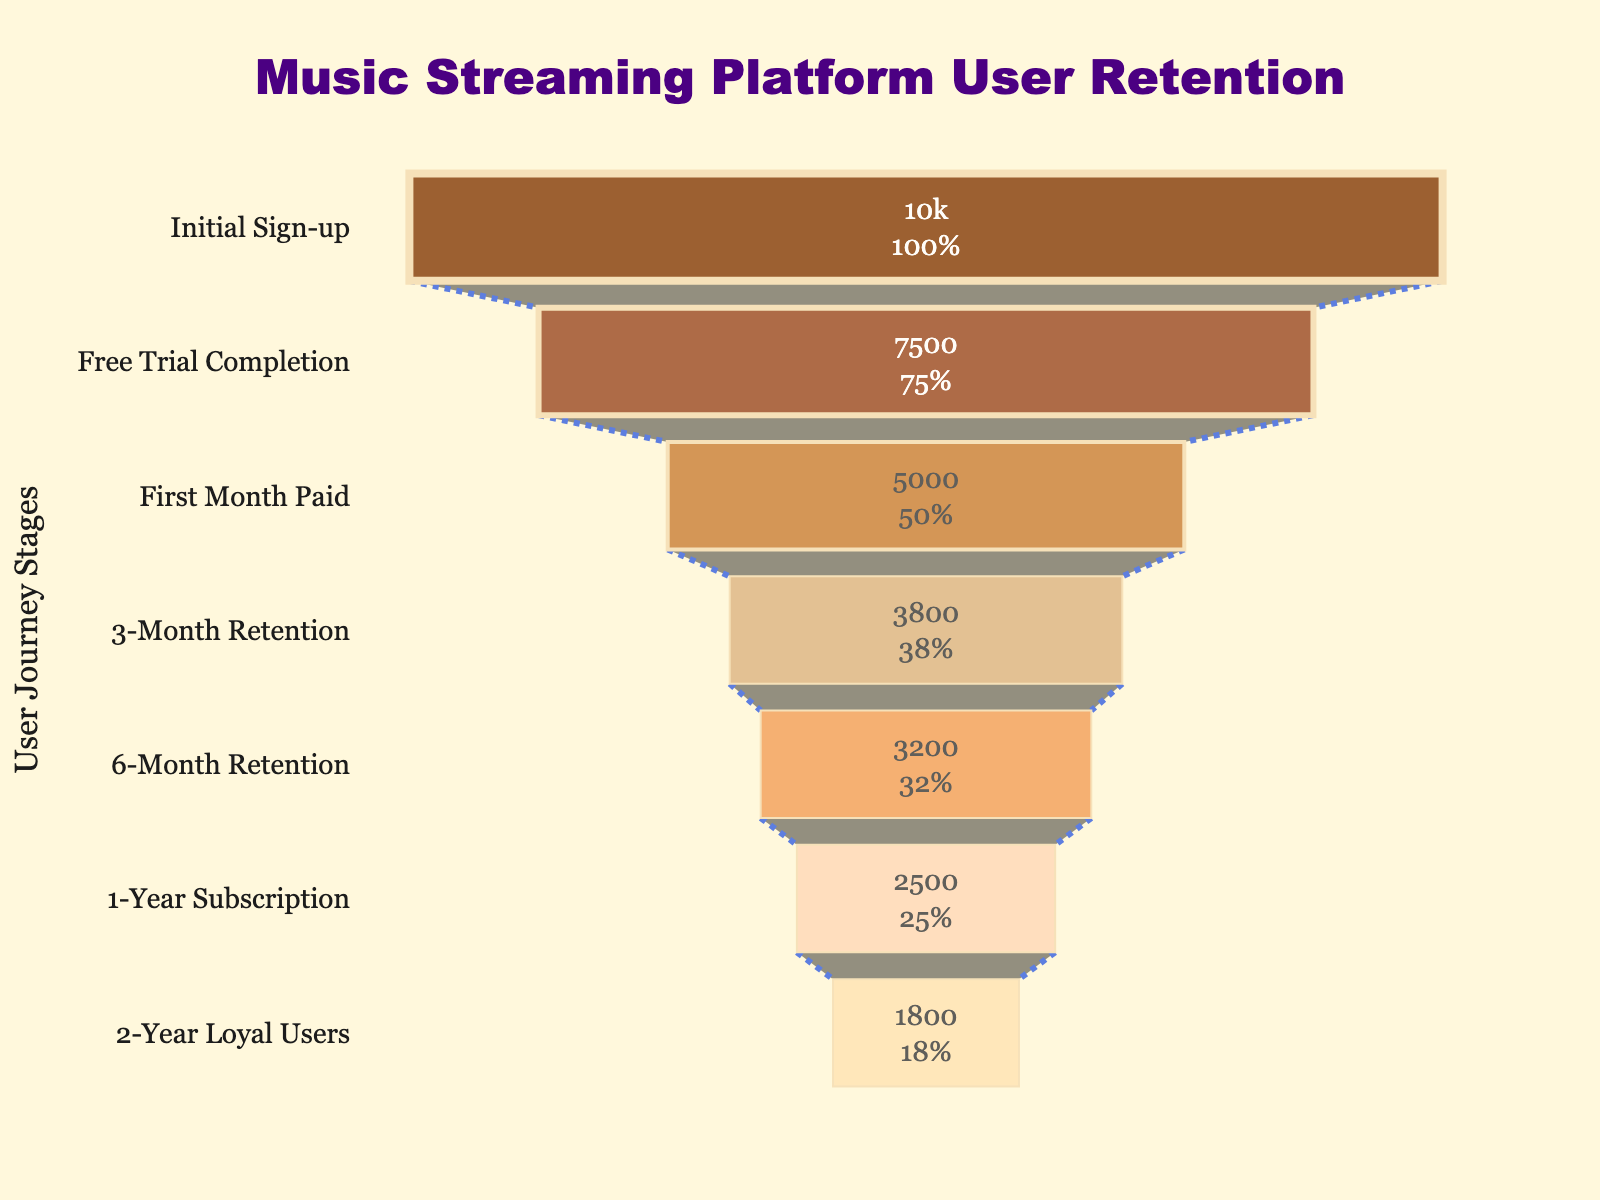What is the title of the Funnel Chart? The title of the chart is usually placed at the top center of the figure. In this case, it reads "Music Streaming Platform User Retention".
Answer: Music Streaming Platform User Retention How many users completed the Free Trial stage? Look at the number of users listed for the "Free Trial Completion" stage, which is the second stage in the chart.
Answer: 7500 What is the difference in user numbers between "First Month Paid" and "1-Year Subscription"? Find the number of users in both stages, which are respectively 5000 and 2500. Subtract the "1-Year Subscription" users from the "First Month Paid" users: 5000 - 2500 = 2500.
Answer: 2500 Which stage shows the steepest drop in user numbers? To find the steepest drop in user numbers, compare the difference in user counts between consecutive stages. The largest difference is between "Initial Sign-up" (10000) and "Free Trial Completion" (7500), a drop of 2500 users.
Answer: From Initial Sign-up to Free Trial Completion How many users are retained from the "6-Month Retention" stage to the "2-Year Loyal Users" stage? Count the number of users at the "6-Month Retention" stage (3200) and the "2-Year Loyal Users" stage (1800). Subtract the latter from the former: 3200 - 1800 = 1400.
Answer: 1400 What percentage of users who signed up initially are still loyal after 2 years? Look at the initial number of users (10000) and the number of users at the "2-Year Loyal Users" stage (1800). Calculate the percentage: (1800 / 10000) * 100 = 18%.
Answer: 18% How many more users are there at the "3-Month Retention" stage compared to the "1-Year Subscription" stage? Compare the user numbers at the "3-Month Retention" (3800) and "1-Year Subscription" (2500) stages. Subtract the number of "1-Year Subscription" users from the "3-Month Retention" users: 3800 - 2500 = 1300.
Answer: 1300 What is the retention rate from "Free Trial Completion" to "First Month Paid"? The "Free Trial Completion" stage has 7500 users, and the "First Month Paid" stage has 5000 users. The retention rate is (5000 / 7500) * 100 = 66.67%.
Answer: 66.67% Which stage has the lowest number of users? Review the stages and their user counts; the stage with the lowest count is the "2-Year Loyal Users" with 1800 users.
Answer: 2-Year Loyal Users 